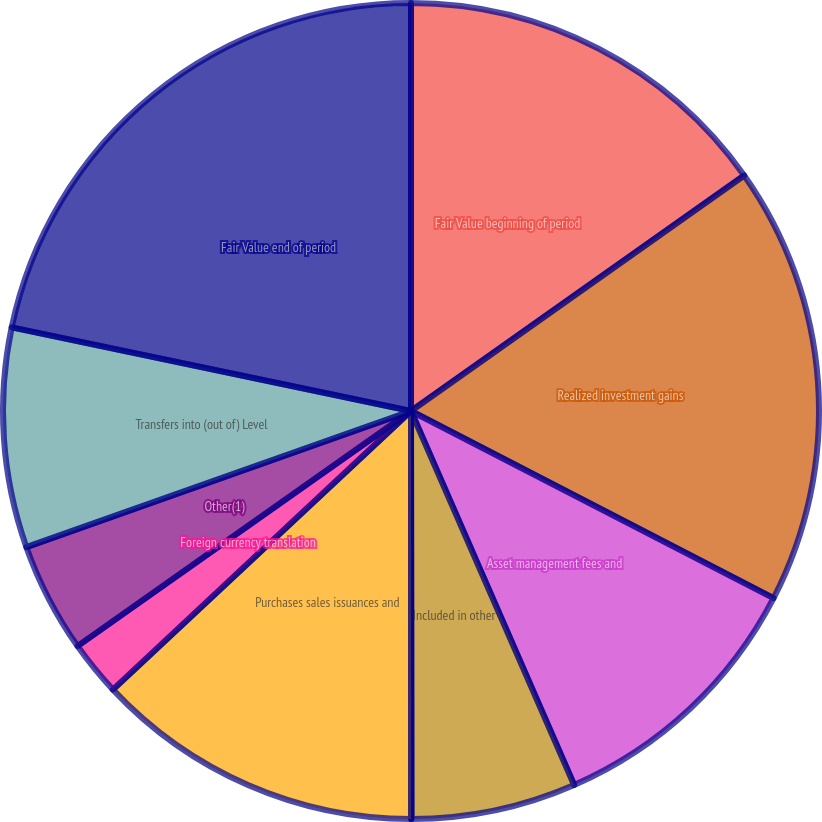Convert chart to OTSL. <chart><loc_0><loc_0><loc_500><loc_500><pie_chart><fcel>Fair Value beginning of period<fcel>Realized investment gains<fcel>Asset management fees and<fcel>Included in other<fcel>Net investment income<fcel>Purchases sales issuances and<fcel>Foreign currency translation<fcel>Other(1)<fcel>Transfers into (out of) Level<fcel>Fair Value end of period<nl><fcel>15.21%<fcel>17.38%<fcel>10.87%<fcel>6.53%<fcel>0.02%<fcel>13.04%<fcel>2.19%<fcel>4.36%<fcel>8.7%<fcel>21.72%<nl></chart> 